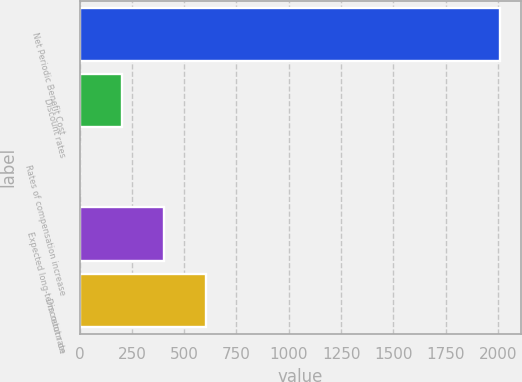Convert chart. <chart><loc_0><loc_0><loc_500><loc_500><bar_chart><fcel>Net Periodic Benefit Cost<fcel>Discount rates<fcel>Rates of compensation increase<fcel>Expected long-term return on<fcel>Discount rate<nl><fcel>2011<fcel>203.3<fcel>2.44<fcel>404.16<fcel>605.02<nl></chart> 